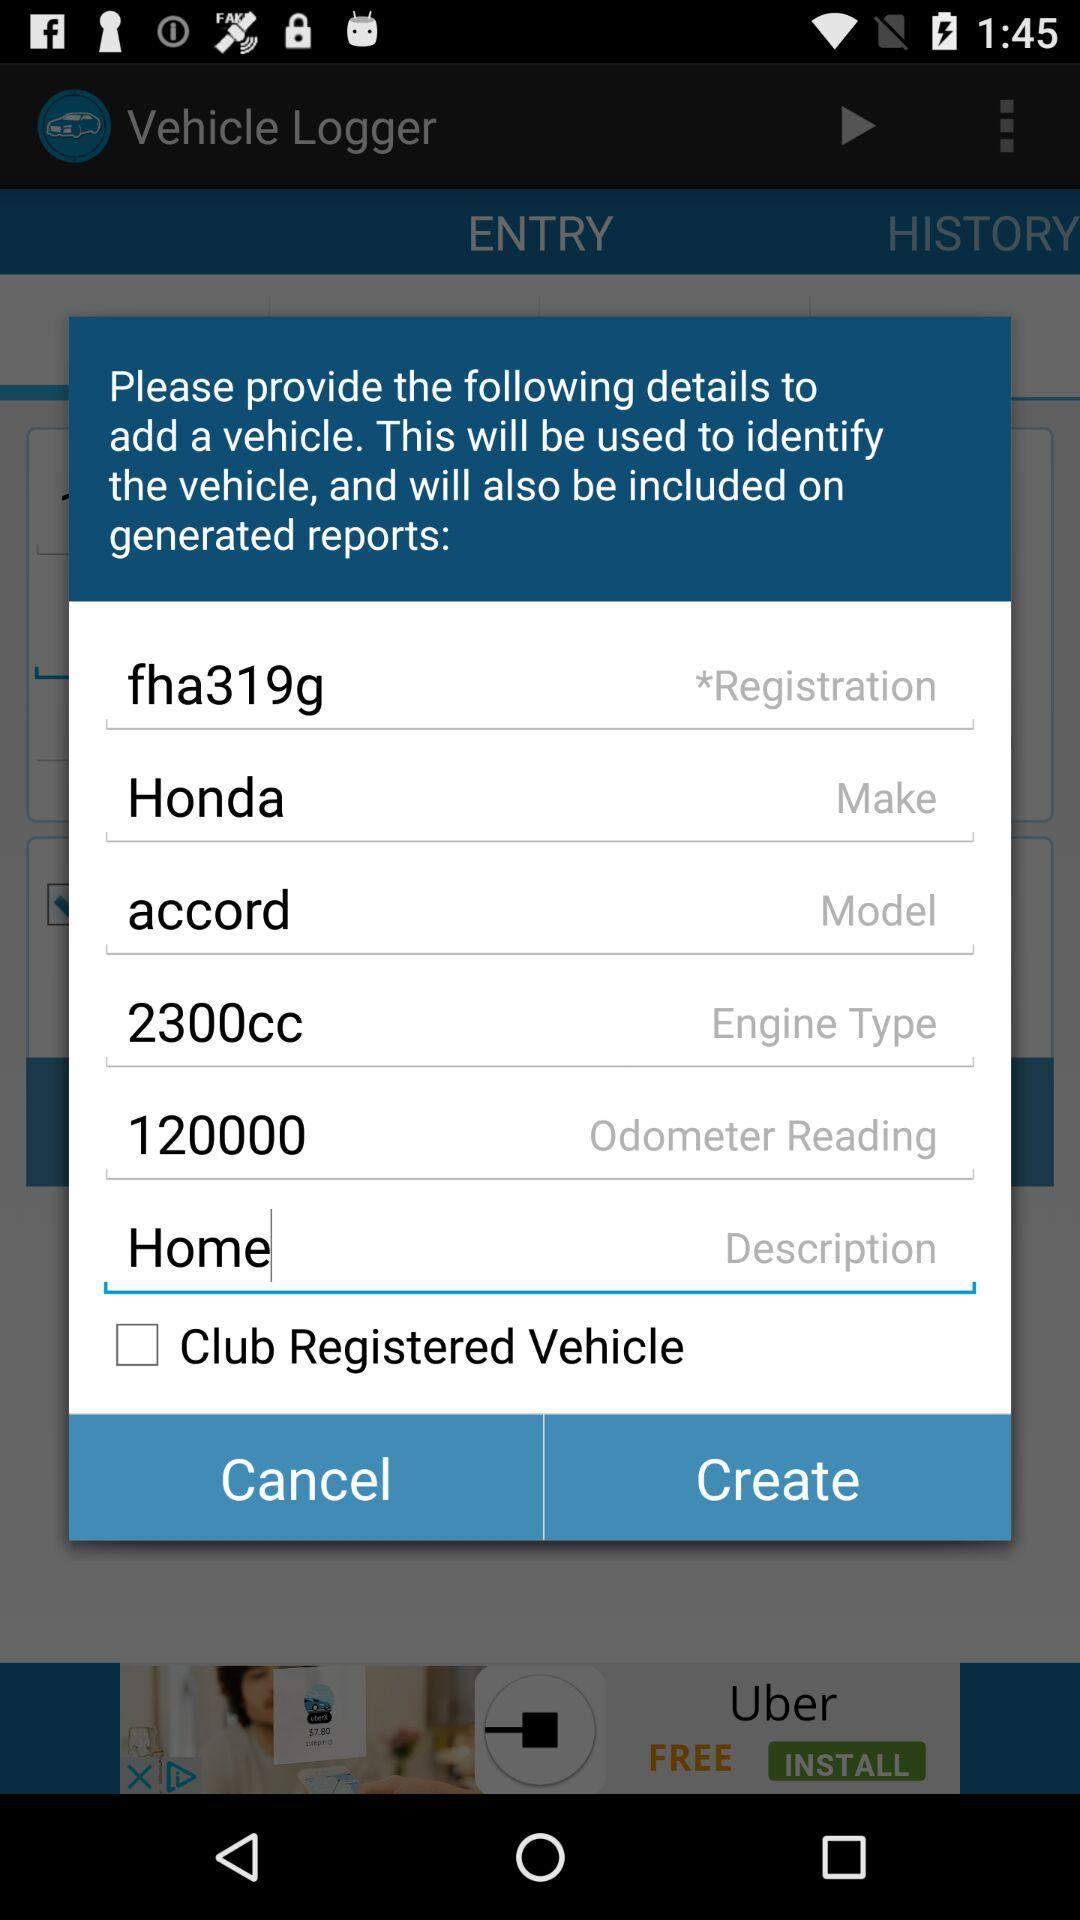What is the odometer reading? The odometer reading is 120000. 